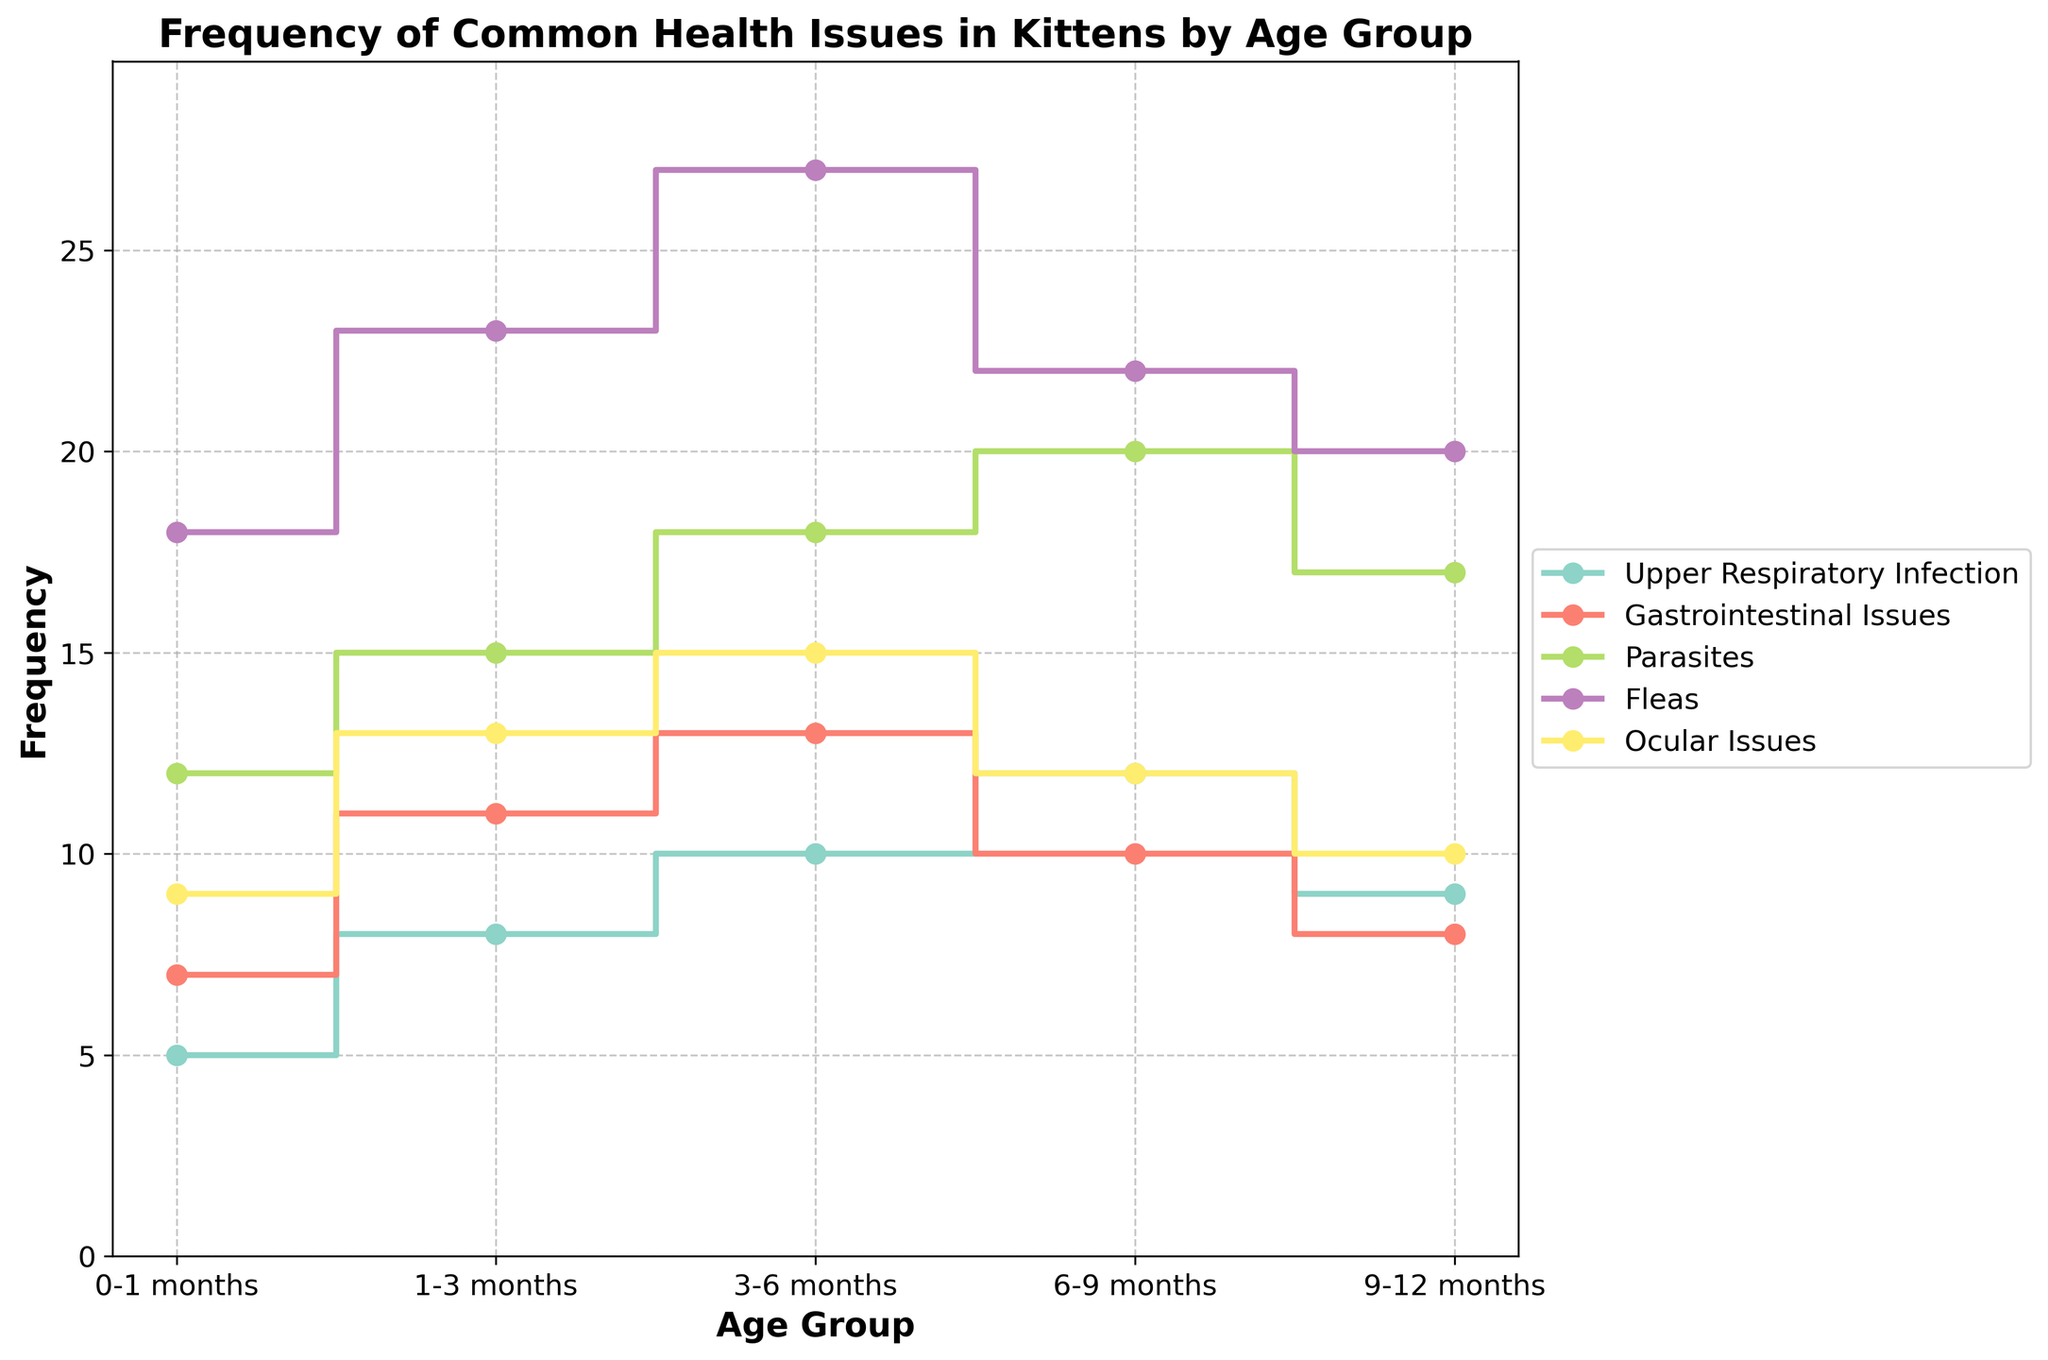What's the highest frequency of Fleas in any age group? The Fleas data series shows the counts across various age groups. Identifying the maximum value involves pinpointing the peak frequency. The particular values for Fleas across the age groups are 18, 23, 27, 22, and 20. The highest value among these is 27.
Answer: 27 Which age group has the lowest frequency for Gastrointestinal Issues? By examining each age group's value for Gastrointestinal Issues, we identify the lowest count. The frequencies are 7, 11, 13, 10, and 8 for the respective age groups. The least frequent occurrence is 7, observed in the 0-1 months age group.
Answer: 0-1 months What is the total number of Upper Respiratory Infection cases across all age groups? Add the frequencies from each age group for Upper Respiratory Infection: 5 (0-1 months) + 8 (1-3 months) + 10 (3-6 months) + 12 (6-9 months) + 9 (9-12 months). Summing these gives 44.
Answer: 44 Between 3-6 months and 6-9 months, which age group has a higher frequency of Parasites? Compare the values for Parasites in the 3-6 months (18) and the 6-9 months (20) age groups. The value for the 6-9 months age group is higher.
Answer: 6-9 months For the age group 9-12 months, which health issue has the highest frequency? Evaluate the frequencies for each health issue in the 9-12 months age group. Parasites: 17, Fleas: 20, Ocular Issues: 10, Upper Respiratory Infection: 9, and Gastrointestinal Issues: 8. Fleas have the highest count at 20.
Answer: Fleas What is the average frequency of Ocular Issues across all age groups? Sum the frequencies for Ocular Issues: 9 (0-1 months) + 13 (1-3 months) + 15 (3-6 months) + 12 (6-9 months) + 10 (9-12 months), which equals 59. Dividing this total by the number of age groups (5) results in an average of 11.8.
Answer: 11.8 Which health issue shows an increase in frequency at each subsequent age group up to 6-9 months? Reviewing the data for each health issue and age group shows Fleas increases consistently from 18 (0-1 months) to 23 (1-3 months), 27 (3-6 months), then dips at 22 (6-9 months). Upper Respiratory Infection, Gastrointestinal Issues, Parasites, and Ocular Issues do not consistently increase. Thus, no health issue shows a continually increasing trend.
Answer: None How many age groups have a higher frequency of Gastrointestinal Issues than Ocular Issues? Comparing Gastrointestinal Issues and Ocular Issues values for each age group reveals: 
0-1 months: 7 (GI) vs 9 (Ocular)
1-3 months: 11 (GI) vs 13 (Ocular)
3-6 months: 13 (GI) vs 15 (Ocular)
6-9 months: 10 (GI) vs 12 (Ocular)
9-12 months: 8 (GI) vs 10 (Ocular). All 5 age groups show lower Gastrointestinal Issues compared to Ocular Issues.
Answer: 0 What is the difference in the highest and lowest frequencies of Parasites across all age groups? Identify the highest frequency (20) and the lowest frequency (12) for Parasites. The difference is 20 - 12, which equals 8.
Answer: 8 